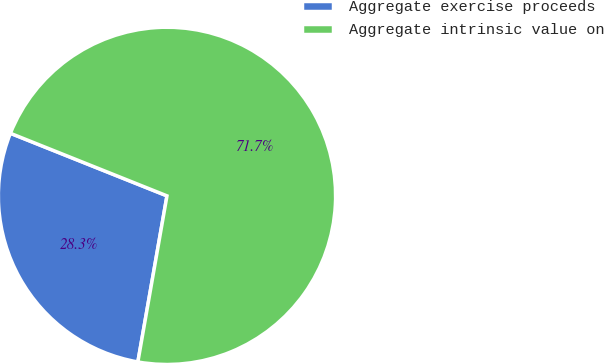<chart> <loc_0><loc_0><loc_500><loc_500><pie_chart><fcel>Aggregate exercise proceeds<fcel>Aggregate intrinsic value on<nl><fcel>28.29%<fcel>71.71%<nl></chart> 